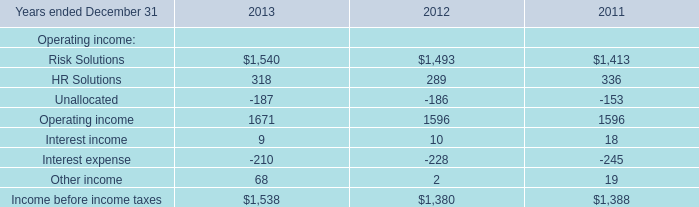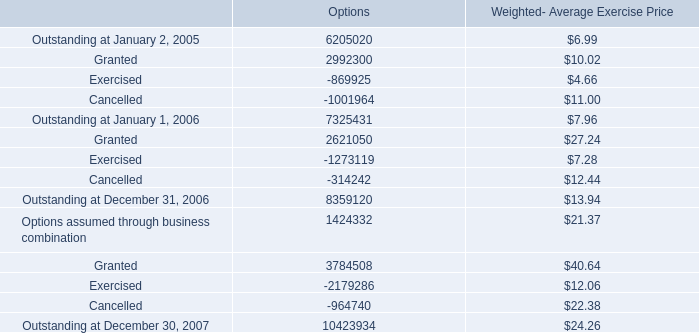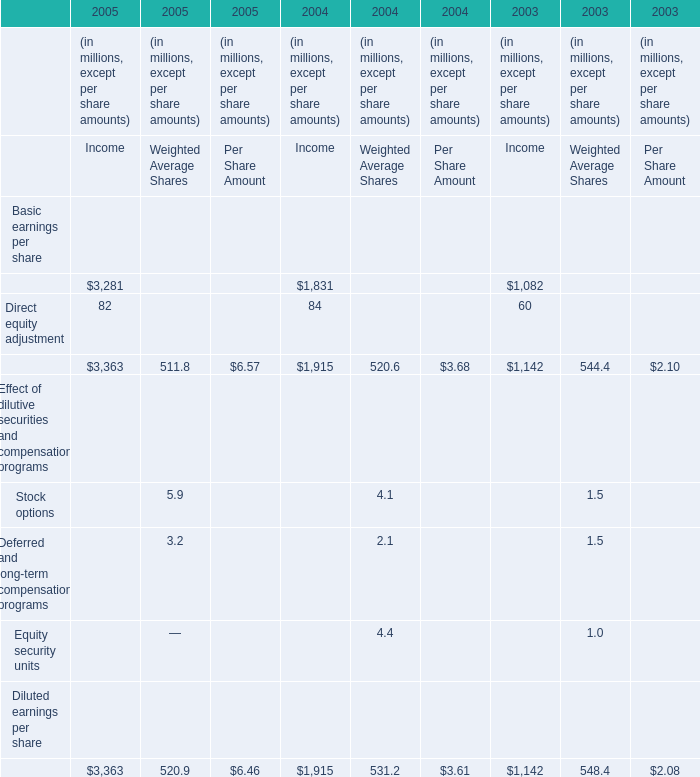what is the total value of granted options in 2006 , in millions? 
Computations: ((2621050 * 27.24) / 1000000)
Answer: 71.3974. 